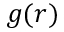<formula> <loc_0><loc_0><loc_500><loc_500>g ( r )</formula> 